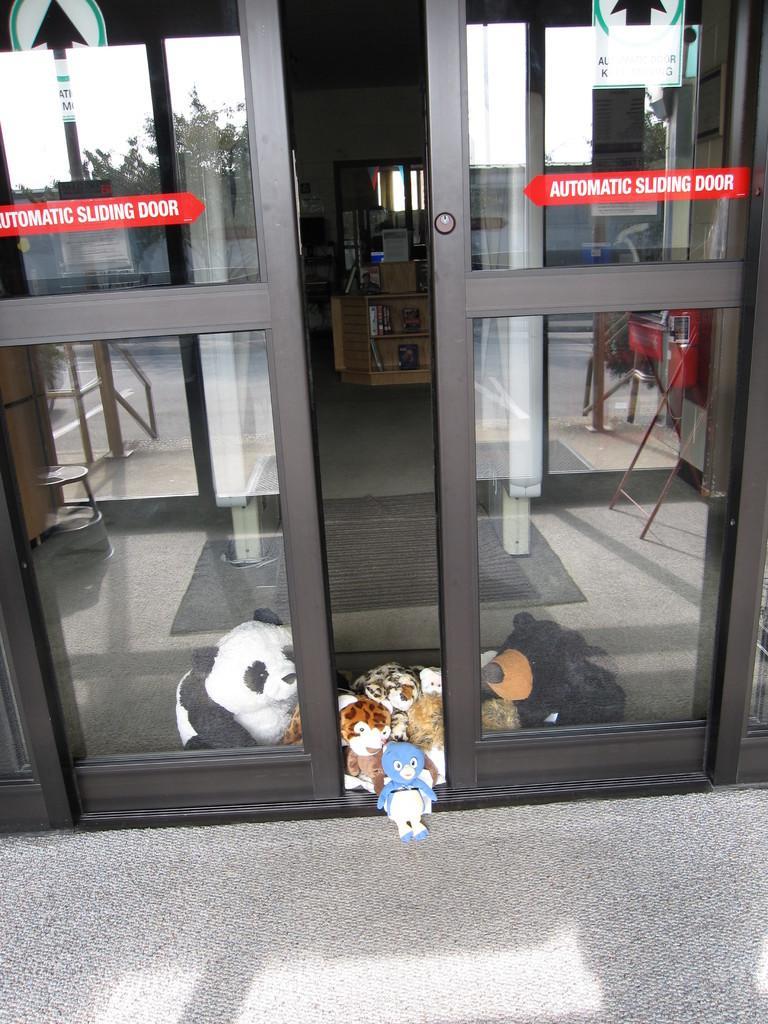Can you describe this image briefly? In this image there is a glass door as we can see in middle of this image and there is a table in middle of this image. There are some dolls are kept on the floor at bottom of this image. 